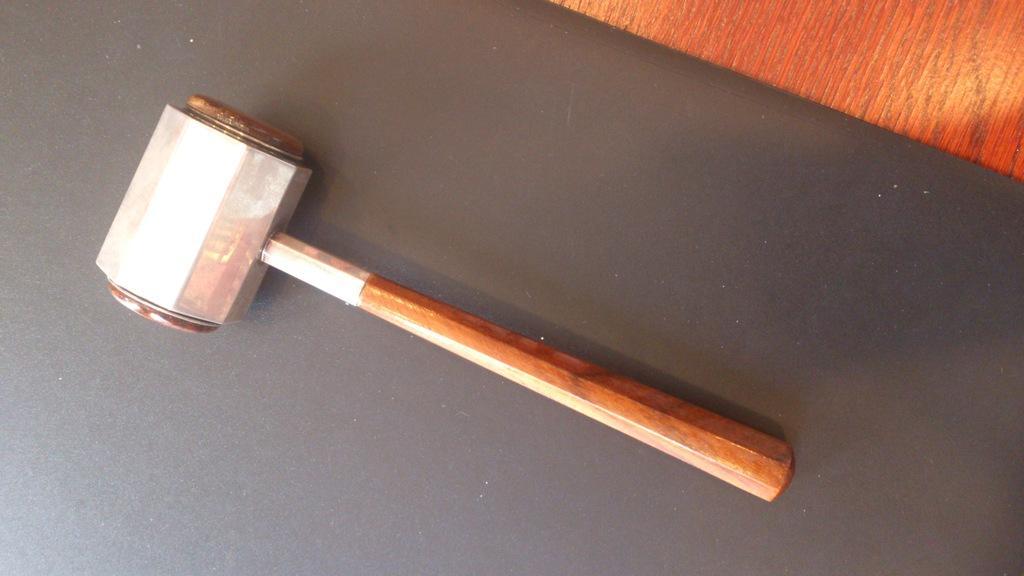Describe this image in one or two sentences. In this image there is a hammer which is on the black colour surface and on the top right there is an object which is brown in colour. 